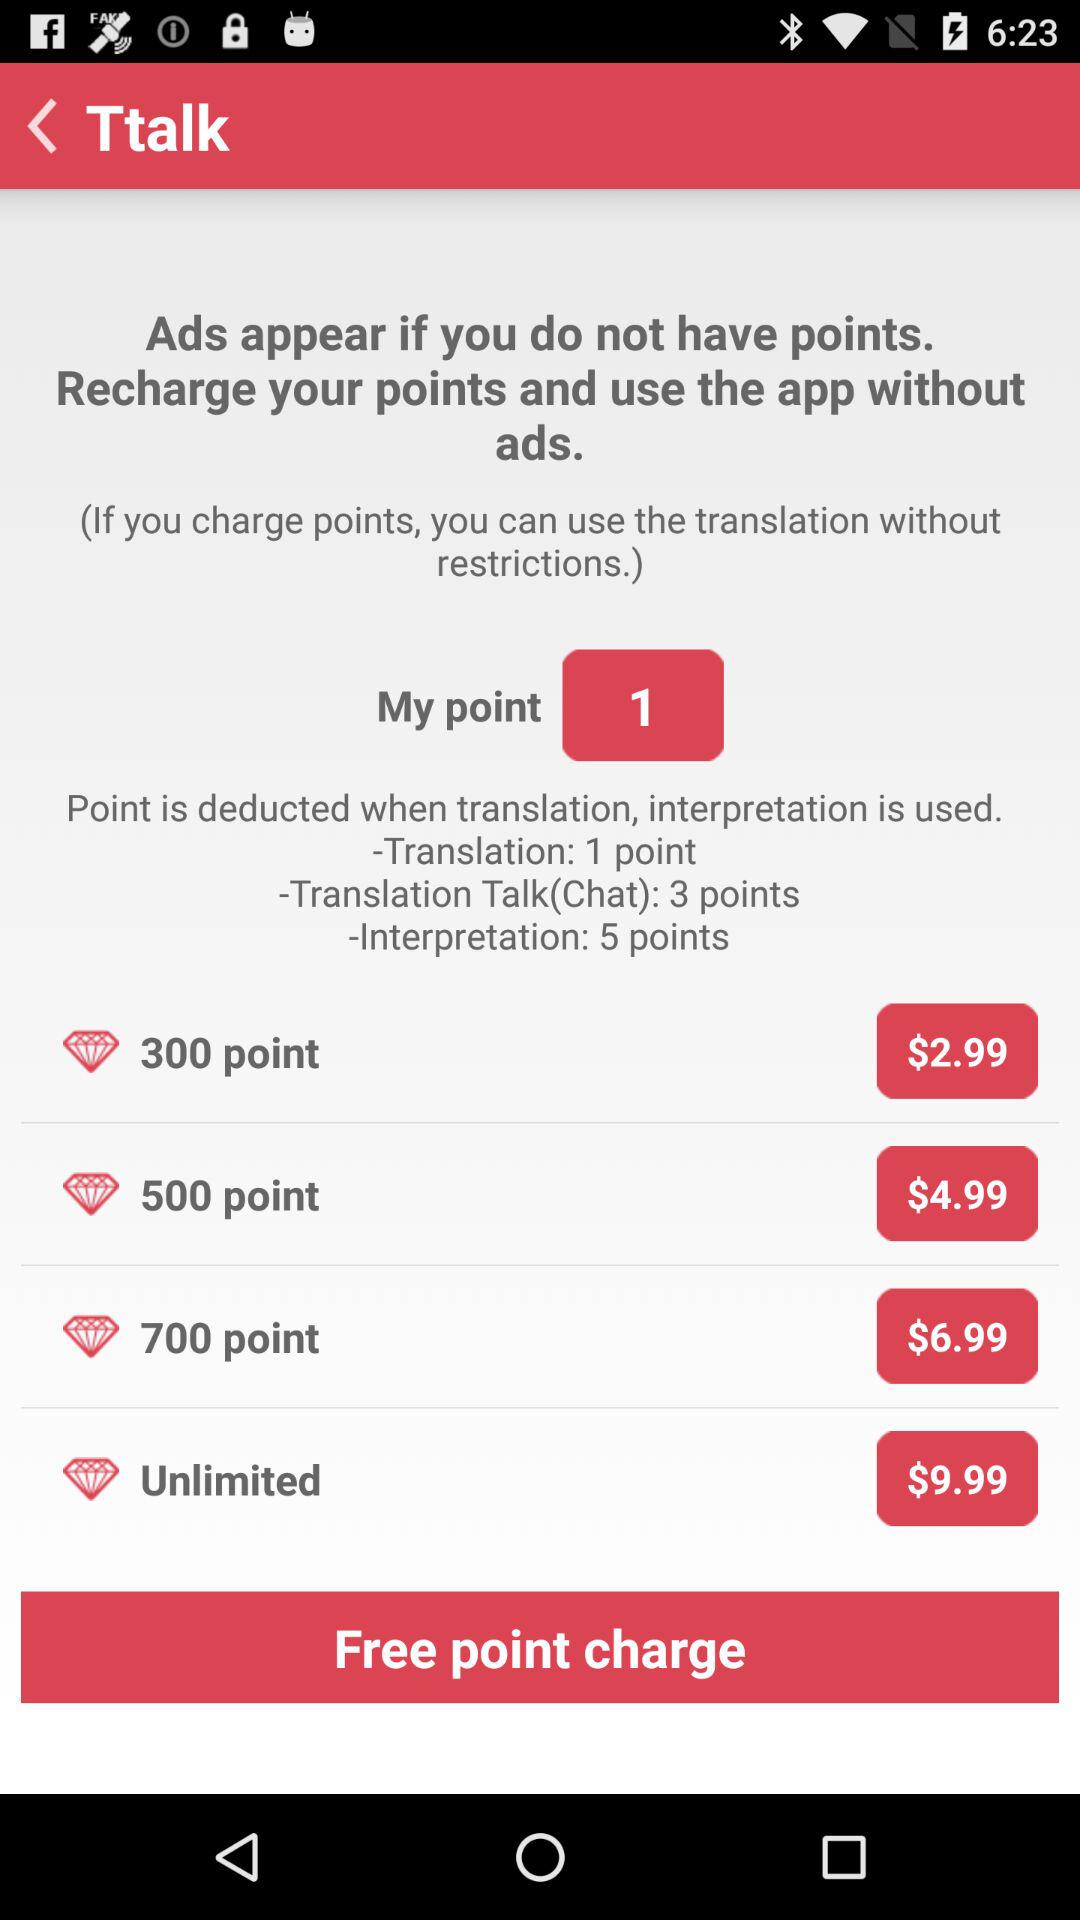How much does it cost to recharge 500 points? It costs $4.99 to recharge 500 points. 